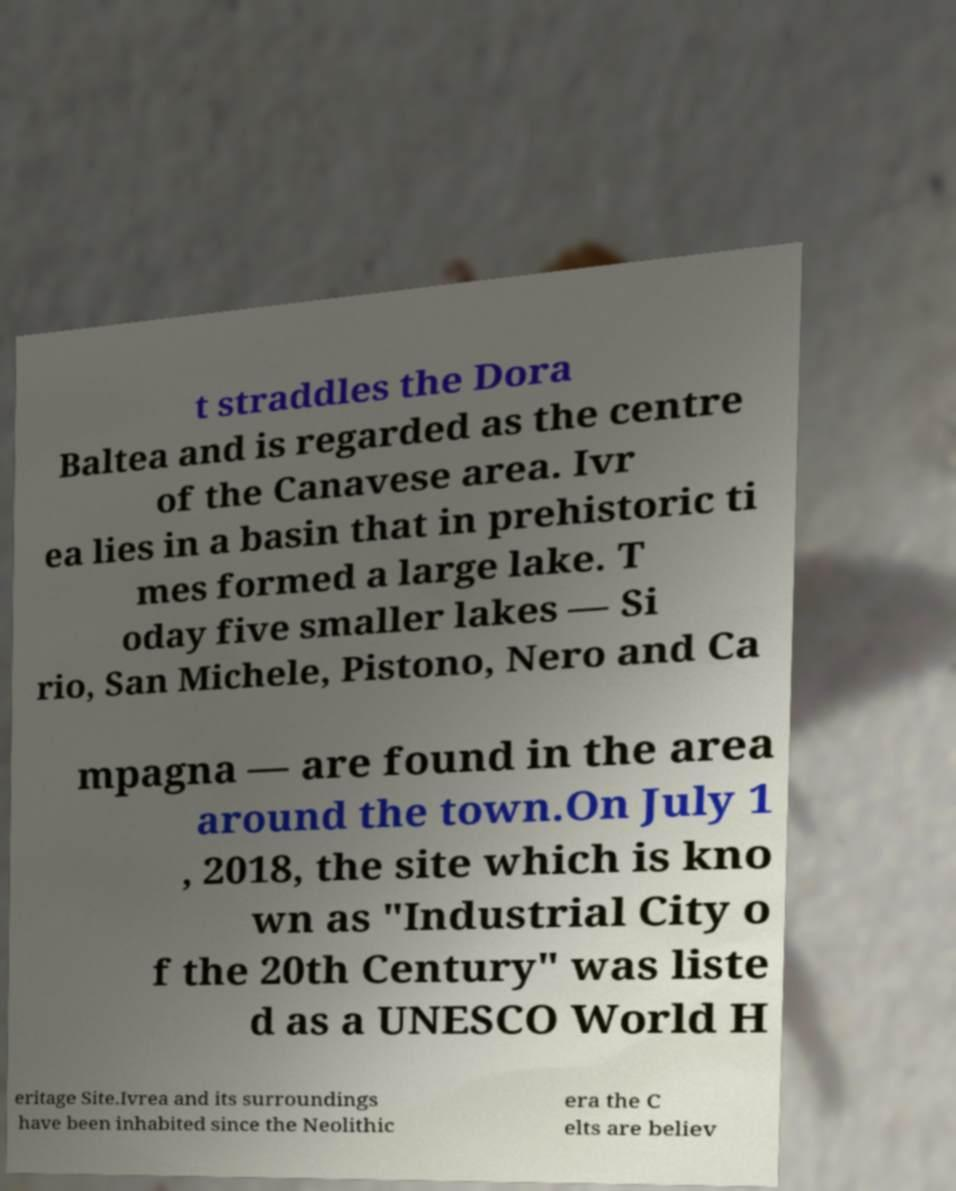What messages or text are displayed in this image? I need them in a readable, typed format. t straddles the Dora Baltea and is regarded as the centre of the Canavese area. Ivr ea lies in a basin that in prehistoric ti mes formed a large lake. T oday five smaller lakes — Si rio, San Michele, Pistono, Nero and Ca mpagna — are found in the area around the town.On July 1 , 2018, the site which is kno wn as "Industrial City o f the 20th Century" was liste d as a UNESCO World H eritage Site.Ivrea and its surroundings have been inhabited since the Neolithic era the C elts are believ 